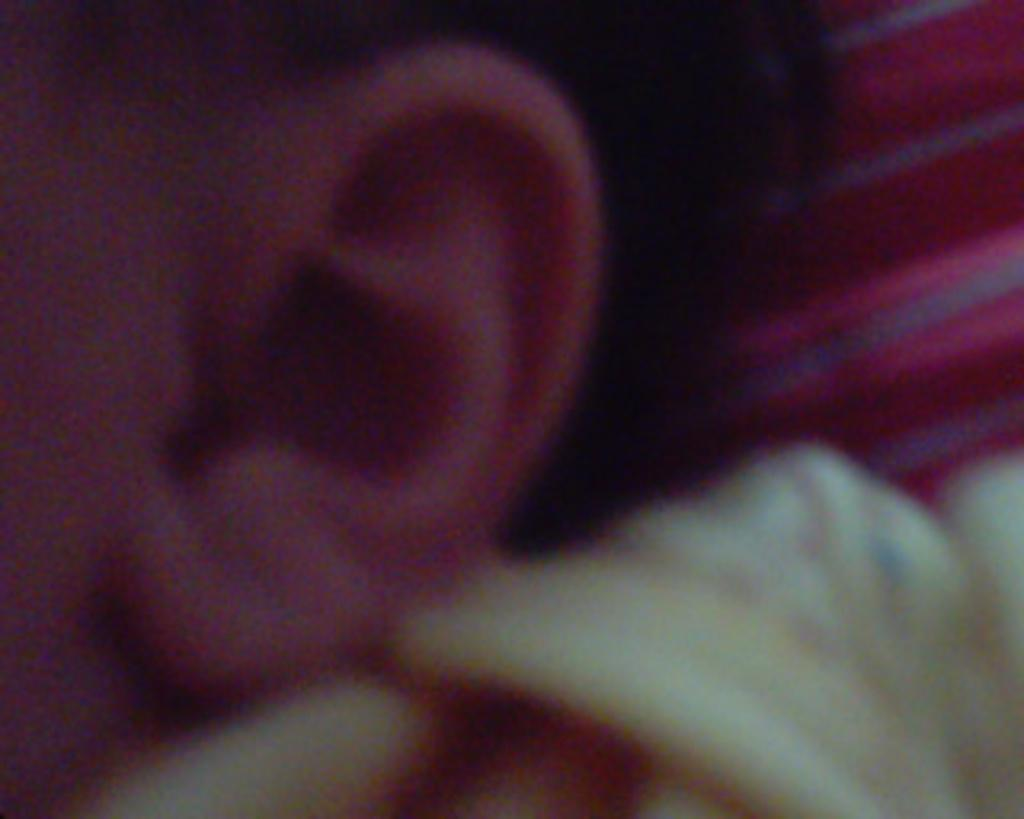What part of the body can be seen in the image? There is an ear visible in the image. What type of playground equipment can be seen in the image? There is no playground equipment present in the image; it only features an ear. 